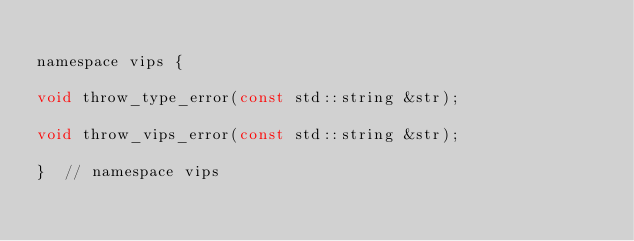Convert code to text. <code><loc_0><loc_0><loc_500><loc_500><_C_>
namespace vips {

void throw_type_error(const std::string &str);

void throw_vips_error(const std::string &str);

}  // namespace vips</code> 